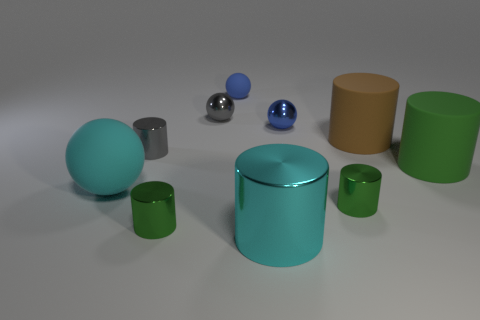The big thing that is the same shape as the tiny blue matte object is what color?
Keep it short and to the point. Cyan. How many balls have the same color as the big metal object?
Provide a succinct answer. 1. Is there anything else that has the same shape as the cyan rubber thing?
Your answer should be very brief. Yes. Are there any matte objects that are in front of the large matte thing that is in front of the green cylinder that is on the right side of the brown rubber cylinder?
Your response must be concise. No. How many other green things are the same material as the big green object?
Your answer should be compact. 0. There is a matte ball that is in front of the large green rubber object; does it have the same size as the blue thing right of the blue matte object?
Make the answer very short. No. There is a large cylinder in front of the small green object that is left of the tiny blue matte object that is on the left side of the green rubber cylinder; what is its color?
Make the answer very short. Cyan. Are there any other big things of the same shape as the big cyan metallic thing?
Offer a terse response. Yes. Are there an equal number of tiny gray metallic things that are in front of the large cyan cylinder and green cylinders that are right of the tiny gray metal ball?
Your answer should be compact. No. Do the big cyan thing that is in front of the large cyan rubber ball and the big green matte object have the same shape?
Your response must be concise. Yes. 